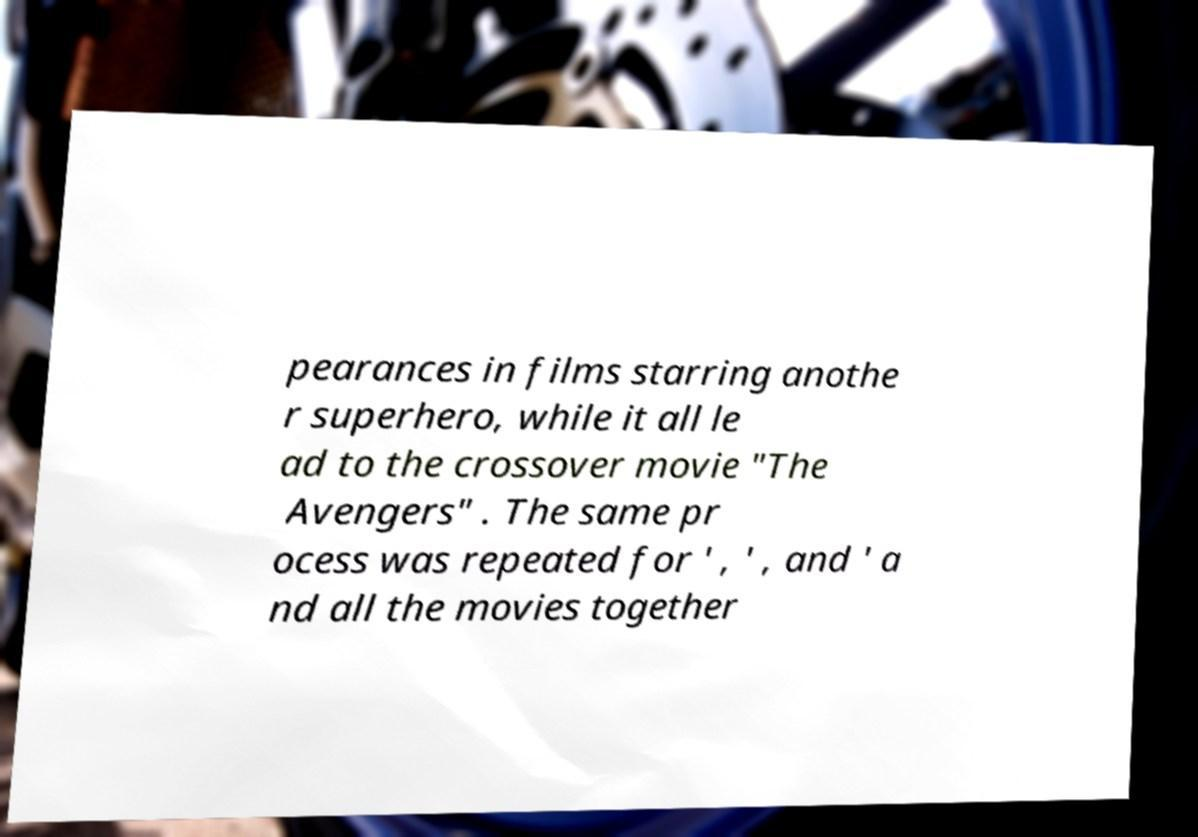Can you accurately transcribe the text from the provided image for me? pearances in films starring anothe r superhero, while it all le ad to the crossover movie "The Avengers" . The same pr ocess was repeated for ' , ' , and ' a nd all the movies together 